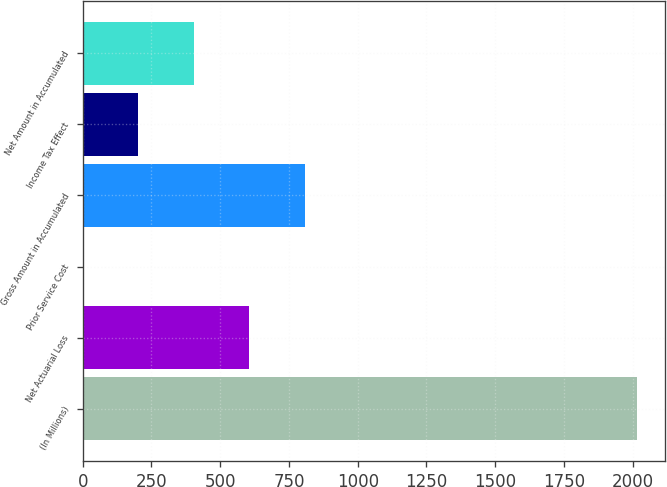Convert chart to OTSL. <chart><loc_0><loc_0><loc_500><loc_500><bar_chart><fcel>(In Millions)<fcel>Net Actuarial Loss<fcel>Prior Service Cost<fcel>Gross Amount in Accumulated<fcel>Income Tax Effect<fcel>Net Amount in Accumulated<nl><fcel>2017<fcel>605.52<fcel>0.6<fcel>807.16<fcel>202.24<fcel>403.88<nl></chart> 